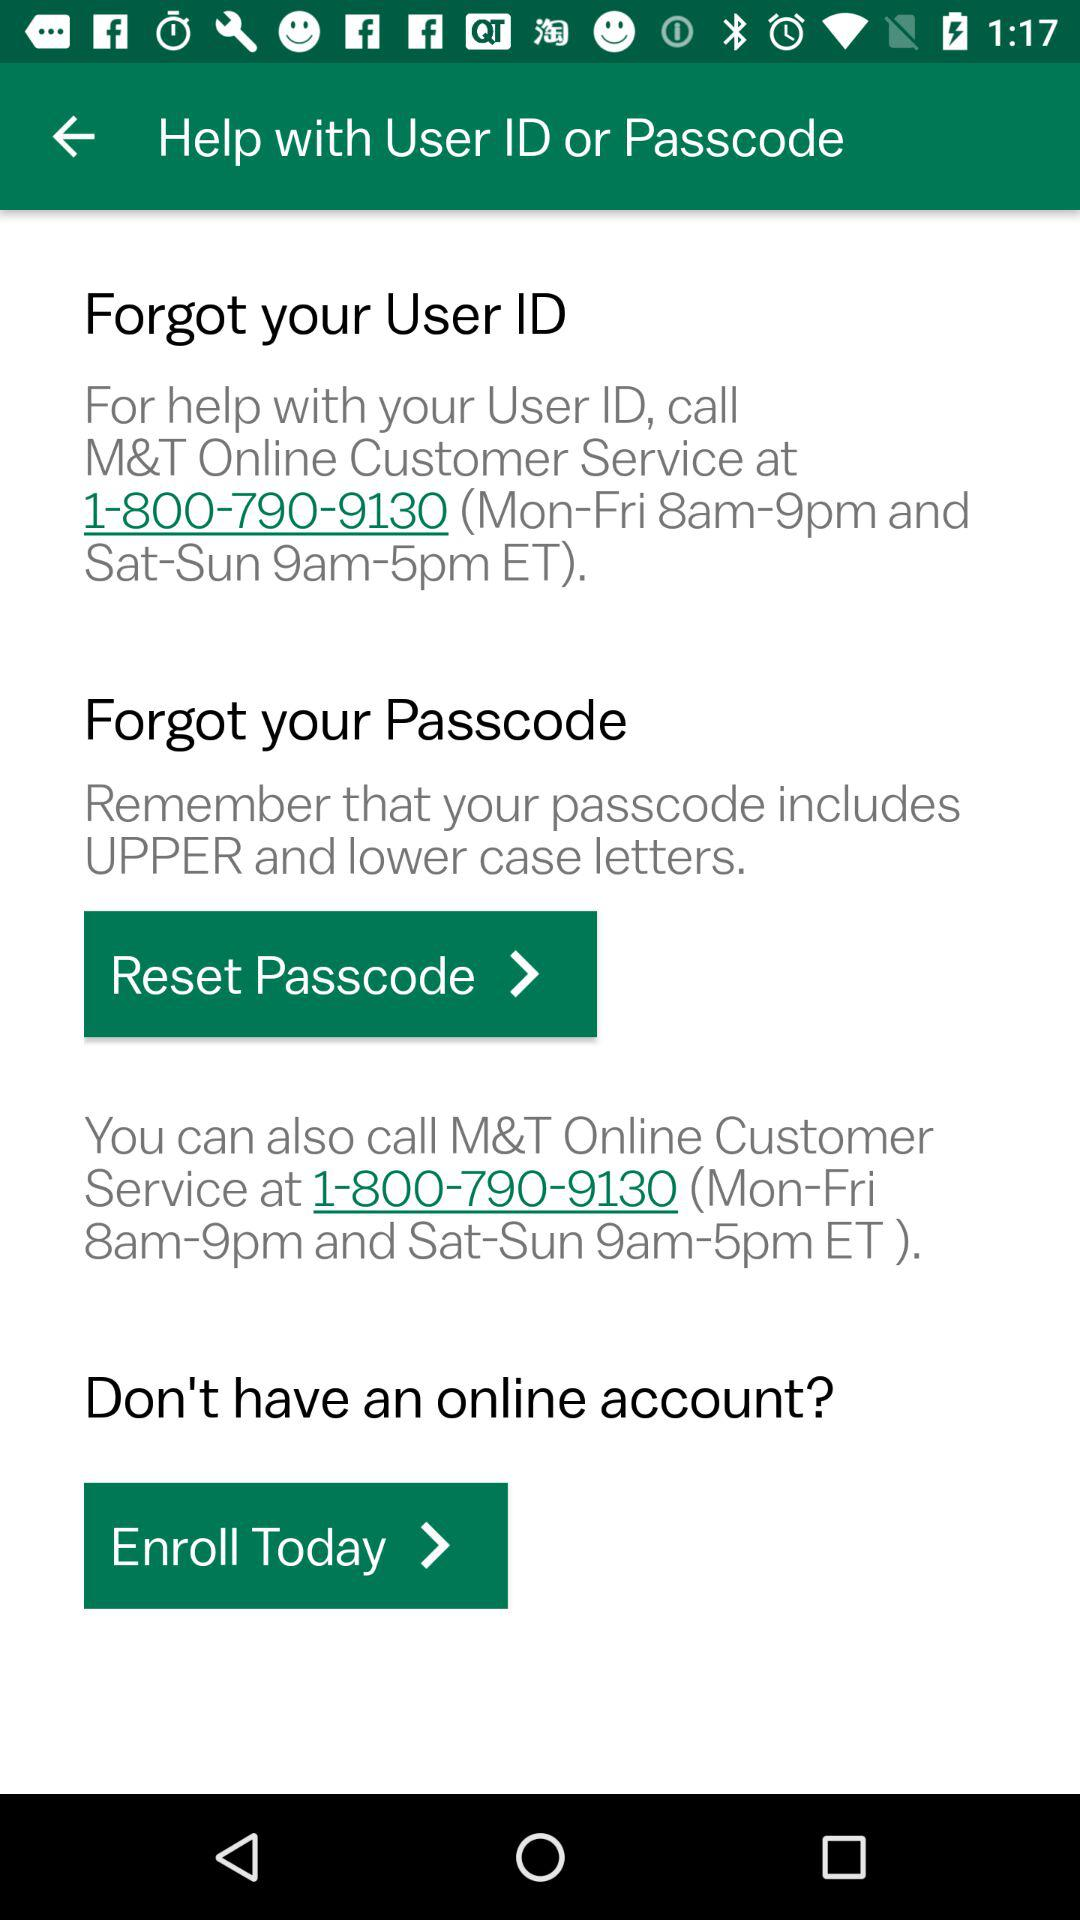At what time can customers contact for help from Monday to Friday? Customers can contact for help between the hours of 8 a.m. and 9 p.m., from Monday to Friday. 